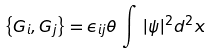Convert formula to latex. <formula><loc_0><loc_0><loc_500><loc_500>\left \{ G _ { i } , G _ { j } \right \} = \epsilon _ { i j } \theta \, \int \, | \psi | ^ { 2 } d ^ { 2 } x</formula> 